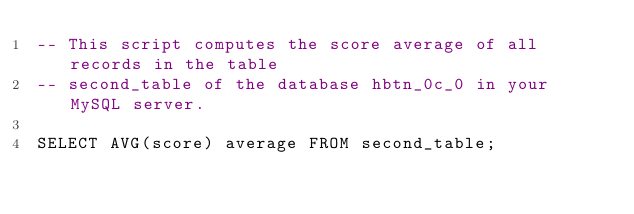<code> <loc_0><loc_0><loc_500><loc_500><_SQL_>-- This script computes the score average of all records in the table
-- second_table of the database hbtn_0c_0 in your MySQL server.

SELECT AVG(score) average FROM second_table;
</code> 